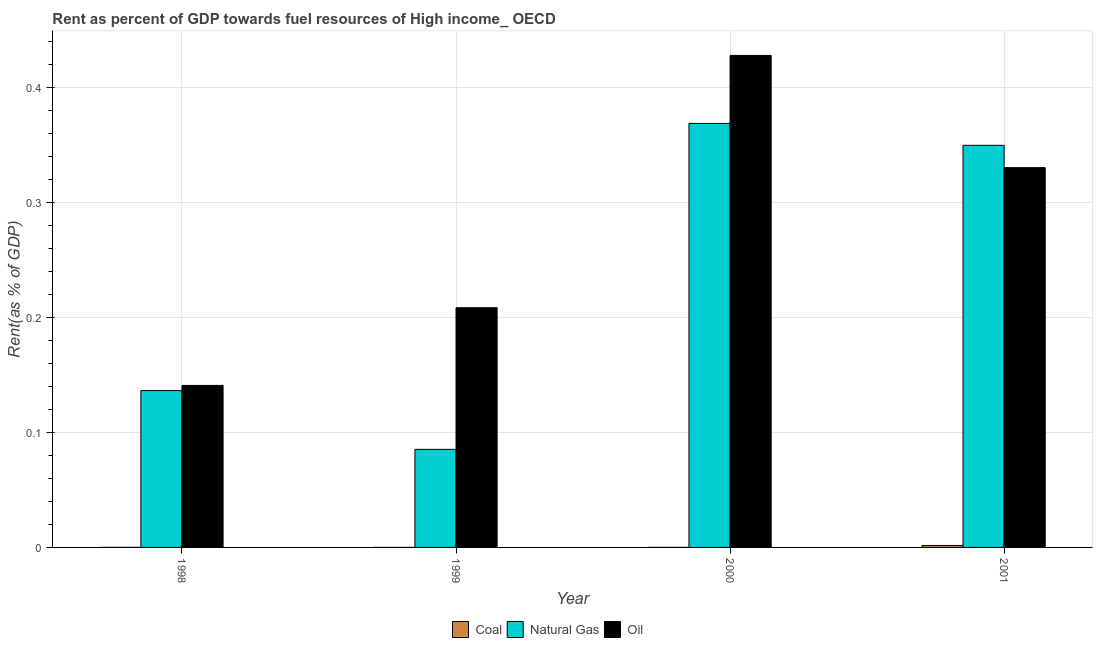How many different coloured bars are there?
Your answer should be compact. 3. Are the number of bars per tick equal to the number of legend labels?
Your answer should be compact. Yes. In how many cases, is the number of bars for a given year not equal to the number of legend labels?
Offer a terse response. 0. What is the rent towards natural gas in 2001?
Keep it short and to the point. 0.35. Across all years, what is the maximum rent towards oil?
Your answer should be compact. 0.43. Across all years, what is the minimum rent towards coal?
Provide a succinct answer. 2.93471039377284e-5. In which year was the rent towards natural gas maximum?
Provide a short and direct response. 2000. What is the total rent towards natural gas in the graph?
Your answer should be compact. 0.94. What is the difference between the rent towards coal in 1999 and that in 2001?
Ensure brevity in your answer.  -0. What is the difference between the rent towards natural gas in 2001 and the rent towards coal in 1998?
Keep it short and to the point. 0.21. What is the average rent towards oil per year?
Keep it short and to the point. 0.28. In how many years, is the rent towards oil greater than 0.30000000000000004 %?
Your answer should be very brief. 2. What is the ratio of the rent towards natural gas in 1998 to that in 1999?
Ensure brevity in your answer.  1.6. What is the difference between the highest and the second highest rent towards coal?
Make the answer very short. 0. What is the difference between the highest and the lowest rent towards natural gas?
Provide a succinct answer. 0.28. In how many years, is the rent towards natural gas greater than the average rent towards natural gas taken over all years?
Offer a terse response. 2. Is the sum of the rent towards natural gas in 2000 and 2001 greater than the maximum rent towards coal across all years?
Make the answer very short. Yes. What does the 2nd bar from the left in 2001 represents?
Provide a succinct answer. Natural Gas. What does the 2nd bar from the right in 2001 represents?
Give a very brief answer. Natural Gas. Are all the bars in the graph horizontal?
Offer a terse response. No. What is the difference between two consecutive major ticks on the Y-axis?
Offer a very short reply. 0.1. Are the values on the major ticks of Y-axis written in scientific E-notation?
Your response must be concise. No. Does the graph contain any zero values?
Make the answer very short. No. Does the graph contain grids?
Ensure brevity in your answer.  Yes. What is the title of the graph?
Keep it short and to the point. Rent as percent of GDP towards fuel resources of High income_ OECD. Does "Ores and metals" appear as one of the legend labels in the graph?
Your answer should be very brief. No. What is the label or title of the X-axis?
Offer a terse response. Year. What is the label or title of the Y-axis?
Offer a terse response. Rent(as % of GDP). What is the Rent(as % of GDP) in Coal in 1998?
Keep it short and to the point. 6.0945704561912e-5. What is the Rent(as % of GDP) in Natural Gas in 1998?
Provide a succinct answer. 0.14. What is the Rent(as % of GDP) in Oil in 1998?
Give a very brief answer. 0.14. What is the Rent(as % of GDP) in Coal in 1999?
Provide a succinct answer. 2.93471039377284e-5. What is the Rent(as % of GDP) in Natural Gas in 1999?
Keep it short and to the point. 0.09. What is the Rent(as % of GDP) in Oil in 1999?
Offer a very short reply. 0.21. What is the Rent(as % of GDP) of Coal in 2000?
Your response must be concise. 5.323208477132929e-5. What is the Rent(as % of GDP) of Natural Gas in 2000?
Your answer should be compact. 0.37. What is the Rent(as % of GDP) in Oil in 2000?
Ensure brevity in your answer.  0.43. What is the Rent(as % of GDP) in Coal in 2001?
Keep it short and to the point. 0. What is the Rent(as % of GDP) of Natural Gas in 2001?
Give a very brief answer. 0.35. What is the Rent(as % of GDP) in Oil in 2001?
Ensure brevity in your answer.  0.33. Across all years, what is the maximum Rent(as % of GDP) of Coal?
Make the answer very short. 0. Across all years, what is the maximum Rent(as % of GDP) of Natural Gas?
Provide a short and direct response. 0.37. Across all years, what is the maximum Rent(as % of GDP) of Oil?
Your answer should be very brief. 0.43. Across all years, what is the minimum Rent(as % of GDP) in Coal?
Your answer should be compact. 2.93471039377284e-5. Across all years, what is the minimum Rent(as % of GDP) of Natural Gas?
Provide a succinct answer. 0.09. Across all years, what is the minimum Rent(as % of GDP) of Oil?
Your answer should be very brief. 0.14. What is the total Rent(as % of GDP) in Coal in the graph?
Your response must be concise. 0. What is the total Rent(as % of GDP) of Natural Gas in the graph?
Your answer should be very brief. 0.94. What is the total Rent(as % of GDP) in Oil in the graph?
Give a very brief answer. 1.11. What is the difference between the Rent(as % of GDP) of Natural Gas in 1998 and that in 1999?
Your response must be concise. 0.05. What is the difference between the Rent(as % of GDP) of Oil in 1998 and that in 1999?
Make the answer very short. -0.07. What is the difference between the Rent(as % of GDP) in Natural Gas in 1998 and that in 2000?
Your answer should be very brief. -0.23. What is the difference between the Rent(as % of GDP) in Oil in 1998 and that in 2000?
Make the answer very short. -0.29. What is the difference between the Rent(as % of GDP) in Coal in 1998 and that in 2001?
Provide a succinct answer. -0. What is the difference between the Rent(as % of GDP) in Natural Gas in 1998 and that in 2001?
Give a very brief answer. -0.21. What is the difference between the Rent(as % of GDP) of Oil in 1998 and that in 2001?
Offer a terse response. -0.19. What is the difference between the Rent(as % of GDP) in Natural Gas in 1999 and that in 2000?
Your response must be concise. -0.28. What is the difference between the Rent(as % of GDP) in Oil in 1999 and that in 2000?
Make the answer very short. -0.22. What is the difference between the Rent(as % of GDP) in Coal in 1999 and that in 2001?
Your response must be concise. -0. What is the difference between the Rent(as % of GDP) in Natural Gas in 1999 and that in 2001?
Make the answer very short. -0.26. What is the difference between the Rent(as % of GDP) in Oil in 1999 and that in 2001?
Provide a succinct answer. -0.12. What is the difference between the Rent(as % of GDP) in Coal in 2000 and that in 2001?
Make the answer very short. -0. What is the difference between the Rent(as % of GDP) in Natural Gas in 2000 and that in 2001?
Ensure brevity in your answer.  0.02. What is the difference between the Rent(as % of GDP) in Oil in 2000 and that in 2001?
Offer a terse response. 0.1. What is the difference between the Rent(as % of GDP) of Coal in 1998 and the Rent(as % of GDP) of Natural Gas in 1999?
Your answer should be very brief. -0.09. What is the difference between the Rent(as % of GDP) in Coal in 1998 and the Rent(as % of GDP) in Oil in 1999?
Keep it short and to the point. -0.21. What is the difference between the Rent(as % of GDP) of Natural Gas in 1998 and the Rent(as % of GDP) of Oil in 1999?
Ensure brevity in your answer.  -0.07. What is the difference between the Rent(as % of GDP) of Coal in 1998 and the Rent(as % of GDP) of Natural Gas in 2000?
Give a very brief answer. -0.37. What is the difference between the Rent(as % of GDP) in Coal in 1998 and the Rent(as % of GDP) in Oil in 2000?
Give a very brief answer. -0.43. What is the difference between the Rent(as % of GDP) in Natural Gas in 1998 and the Rent(as % of GDP) in Oil in 2000?
Keep it short and to the point. -0.29. What is the difference between the Rent(as % of GDP) in Coal in 1998 and the Rent(as % of GDP) in Natural Gas in 2001?
Give a very brief answer. -0.35. What is the difference between the Rent(as % of GDP) in Coal in 1998 and the Rent(as % of GDP) in Oil in 2001?
Give a very brief answer. -0.33. What is the difference between the Rent(as % of GDP) in Natural Gas in 1998 and the Rent(as % of GDP) in Oil in 2001?
Your answer should be compact. -0.19. What is the difference between the Rent(as % of GDP) in Coal in 1999 and the Rent(as % of GDP) in Natural Gas in 2000?
Keep it short and to the point. -0.37. What is the difference between the Rent(as % of GDP) in Coal in 1999 and the Rent(as % of GDP) in Oil in 2000?
Offer a terse response. -0.43. What is the difference between the Rent(as % of GDP) in Natural Gas in 1999 and the Rent(as % of GDP) in Oil in 2000?
Keep it short and to the point. -0.34. What is the difference between the Rent(as % of GDP) in Coal in 1999 and the Rent(as % of GDP) in Natural Gas in 2001?
Keep it short and to the point. -0.35. What is the difference between the Rent(as % of GDP) of Coal in 1999 and the Rent(as % of GDP) of Oil in 2001?
Ensure brevity in your answer.  -0.33. What is the difference between the Rent(as % of GDP) in Natural Gas in 1999 and the Rent(as % of GDP) in Oil in 2001?
Your answer should be very brief. -0.25. What is the difference between the Rent(as % of GDP) in Coal in 2000 and the Rent(as % of GDP) in Natural Gas in 2001?
Your response must be concise. -0.35. What is the difference between the Rent(as % of GDP) in Coal in 2000 and the Rent(as % of GDP) in Oil in 2001?
Provide a succinct answer. -0.33. What is the difference between the Rent(as % of GDP) in Natural Gas in 2000 and the Rent(as % of GDP) in Oil in 2001?
Your answer should be compact. 0.04. What is the average Rent(as % of GDP) of Coal per year?
Provide a succinct answer. 0. What is the average Rent(as % of GDP) of Natural Gas per year?
Offer a very short reply. 0.24. What is the average Rent(as % of GDP) in Oil per year?
Give a very brief answer. 0.28. In the year 1998, what is the difference between the Rent(as % of GDP) of Coal and Rent(as % of GDP) of Natural Gas?
Make the answer very short. -0.14. In the year 1998, what is the difference between the Rent(as % of GDP) of Coal and Rent(as % of GDP) of Oil?
Keep it short and to the point. -0.14. In the year 1998, what is the difference between the Rent(as % of GDP) of Natural Gas and Rent(as % of GDP) of Oil?
Your response must be concise. -0. In the year 1999, what is the difference between the Rent(as % of GDP) in Coal and Rent(as % of GDP) in Natural Gas?
Offer a terse response. -0.09. In the year 1999, what is the difference between the Rent(as % of GDP) in Coal and Rent(as % of GDP) in Oil?
Offer a very short reply. -0.21. In the year 1999, what is the difference between the Rent(as % of GDP) in Natural Gas and Rent(as % of GDP) in Oil?
Offer a terse response. -0.12. In the year 2000, what is the difference between the Rent(as % of GDP) in Coal and Rent(as % of GDP) in Natural Gas?
Your response must be concise. -0.37. In the year 2000, what is the difference between the Rent(as % of GDP) of Coal and Rent(as % of GDP) of Oil?
Offer a very short reply. -0.43. In the year 2000, what is the difference between the Rent(as % of GDP) in Natural Gas and Rent(as % of GDP) in Oil?
Offer a very short reply. -0.06. In the year 2001, what is the difference between the Rent(as % of GDP) of Coal and Rent(as % of GDP) of Natural Gas?
Provide a short and direct response. -0.35. In the year 2001, what is the difference between the Rent(as % of GDP) in Coal and Rent(as % of GDP) in Oil?
Your response must be concise. -0.33. In the year 2001, what is the difference between the Rent(as % of GDP) in Natural Gas and Rent(as % of GDP) in Oil?
Your response must be concise. 0.02. What is the ratio of the Rent(as % of GDP) of Coal in 1998 to that in 1999?
Offer a terse response. 2.08. What is the ratio of the Rent(as % of GDP) in Natural Gas in 1998 to that in 1999?
Your answer should be compact. 1.6. What is the ratio of the Rent(as % of GDP) in Oil in 1998 to that in 1999?
Offer a terse response. 0.68. What is the ratio of the Rent(as % of GDP) in Coal in 1998 to that in 2000?
Provide a succinct answer. 1.14. What is the ratio of the Rent(as % of GDP) of Natural Gas in 1998 to that in 2000?
Give a very brief answer. 0.37. What is the ratio of the Rent(as % of GDP) of Oil in 1998 to that in 2000?
Give a very brief answer. 0.33. What is the ratio of the Rent(as % of GDP) of Coal in 1998 to that in 2001?
Your response must be concise. 0.04. What is the ratio of the Rent(as % of GDP) in Natural Gas in 1998 to that in 2001?
Give a very brief answer. 0.39. What is the ratio of the Rent(as % of GDP) in Oil in 1998 to that in 2001?
Ensure brevity in your answer.  0.43. What is the ratio of the Rent(as % of GDP) of Coal in 1999 to that in 2000?
Offer a terse response. 0.55. What is the ratio of the Rent(as % of GDP) in Natural Gas in 1999 to that in 2000?
Provide a succinct answer. 0.23. What is the ratio of the Rent(as % of GDP) in Oil in 1999 to that in 2000?
Provide a succinct answer. 0.49. What is the ratio of the Rent(as % of GDP) in Coal in 1999 to that in 2001?
Make the answer very short. 0.02. What is the ratio of the Rent(as % of GDP) of Natural Gas in 1999 to that in 2001?
Provide a succinct answer. 0.24. What is the ratio of the Rent(as % of GDP) in Oil in 1999 to that in 2001?
Your answer should be compact. 0.63. What is the ratio of the Rent(as % of GDP) in Coal in 2000 to that in 2001?
Ensure brevity in your answer.  0.03. What is the ratio of the Rent(as % of GDP) in Natural Gas in 2000 to that in 2001?
Make the answer very short. 1.05. What is the ratio of the Rent(as % of GDP) of Oil in 2000 to that in 2001?
Make the answer very short. 1.3. What is the difference between the highest and the second highest Rent(as % of GDP) of Coal?
Your answer should be compact. 0. What is the difference between the highest and the second highest Rent(as % of GDP) of Natural Gas?
Give a very brief answer. 0.02. What is the difference between the highest and the second highest Rent(as % of GDP) of Oil?
Offer a very short reply. 0.1. What is the difference between the highest and the lowest Rent(as % of GDP) in Coal?
Keep it short and to the point. 0. What is the difference between the highest and the lowest Rent(as % of GDP) of Natural Gas?
Offer a very short reply. 0.28. What is the difference between the highest and the lowest Rent(as % of GDP) in Oil?
Ensure brevity in your answer.  0.29. 